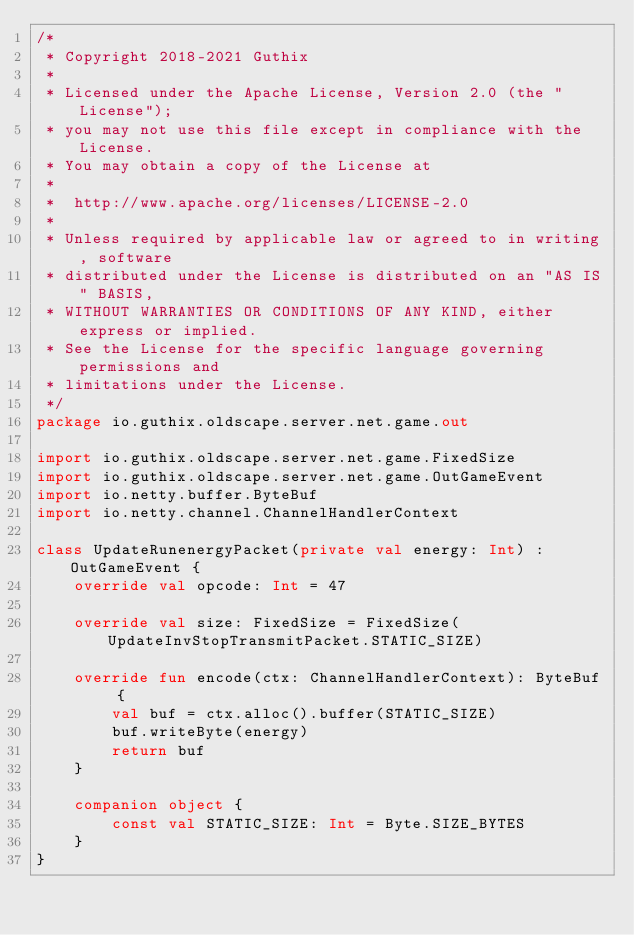Convert code to text. <code><loc_0><loc_0><loc_500><loc_500><_Kotlin_>/*
 * Copyright 2018-2021 Guthix
 *
 * Licensed under the Apache License, Version 2.0 (the "License");
 * you may not use this file except in compliance with the License.
 * You may obtain a copy of the License at
 *
 *  http://www.apache.org/licenses/LICENSE-2.0
 *
 * Unless required by applicable law or agreed to in writing, software
 * distributed under the License is distributed on an "AS IS" BASIS,
 * WITHOUT WARRANTIES OR CONDITIONS OF ANY KIND, either express or implied.
 * See the License for the specific language governing permissions and
 * limitations under the License.
 */
package io.guthix.oldscape.server.net.game.out

import io.guthix.oldscape.server.net.game.FixedSize
import io.guthix.oldscape.server.net.game.OutGameEvent
import io.netty.buffer.ByteBuf
import io.netty.channel.ChannelHandlerContext

class UpdateRunenergyPacket(private val energy: Int) : OutGameEvent {
    override val opcode: Int = 47

    override val size: FixedSize = FixedSize(UpdateInvStopTransmitPacket.STATIC_SIZE)

    override fun encode(ctx: ChannelHandlerContext): ByteBuf {
        val buf = ctx.alloc().buffer(STATIC_SIZE)
        buf.writeByte(energy)
        return buf
    }

    companion object {
        const val STATIC_SIZE: Int = Byte.SIZE_BYTES
    }
}</code> 